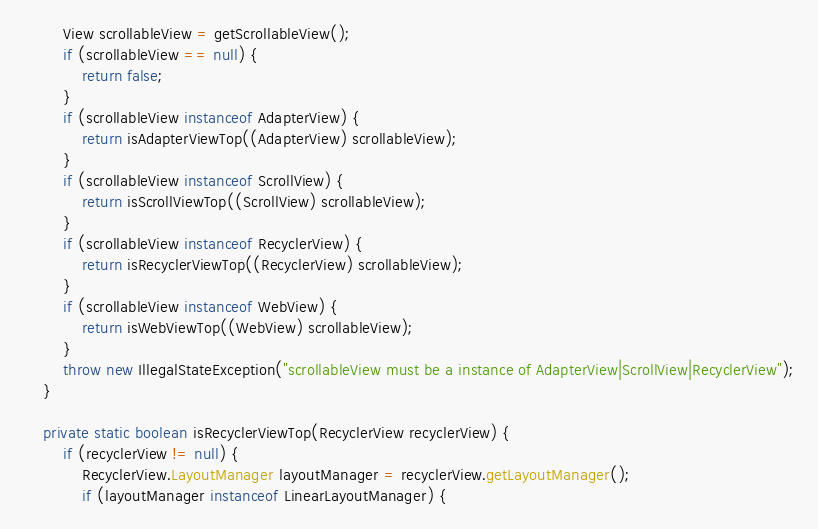Convert code to text. <code><loc_0><loc_0><loc_500><loc_500><_Java_>        View scrollableView = getScrollableView();
        if (scrollableView == null) {
            return false;
        }
        if (scrollableView instanceof AdapterView) {
            return isAdapterViewTop((AdapterView) scrollableView);
        }
        if (scrollableView instanceof ScrollView) {
            return isScrollViewTop((ScrollView) scrollableView);
        }
        if (scrollableView instanceof RecyclerView) {
            return isRecyclerViewTop((RecyclerView) scrollableView);
        }
        if (scrollableView instanceof WebView) {
            return isWebViewTop((WebView) scrollableView);
        }
        throw new IllegalStateException("scrollableView must be a instance of AdapterView|ScrollView|RecyclerView");
    }

    private static boolean isRecyclerViewTop(RecyclerView recyclerView) {
        if (recyclerView != null) {
            RecyclerView.LayoutManager layoutManager = recyclerView.getLayoutManager();
            if (layoutManager instanceof LinearLayoutManager) {</code> 